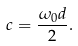<formula> <loc_0><loc_0><loc_500><loc_500>c = \frac { \omega _ { 0 } d } 2 .</formula> 